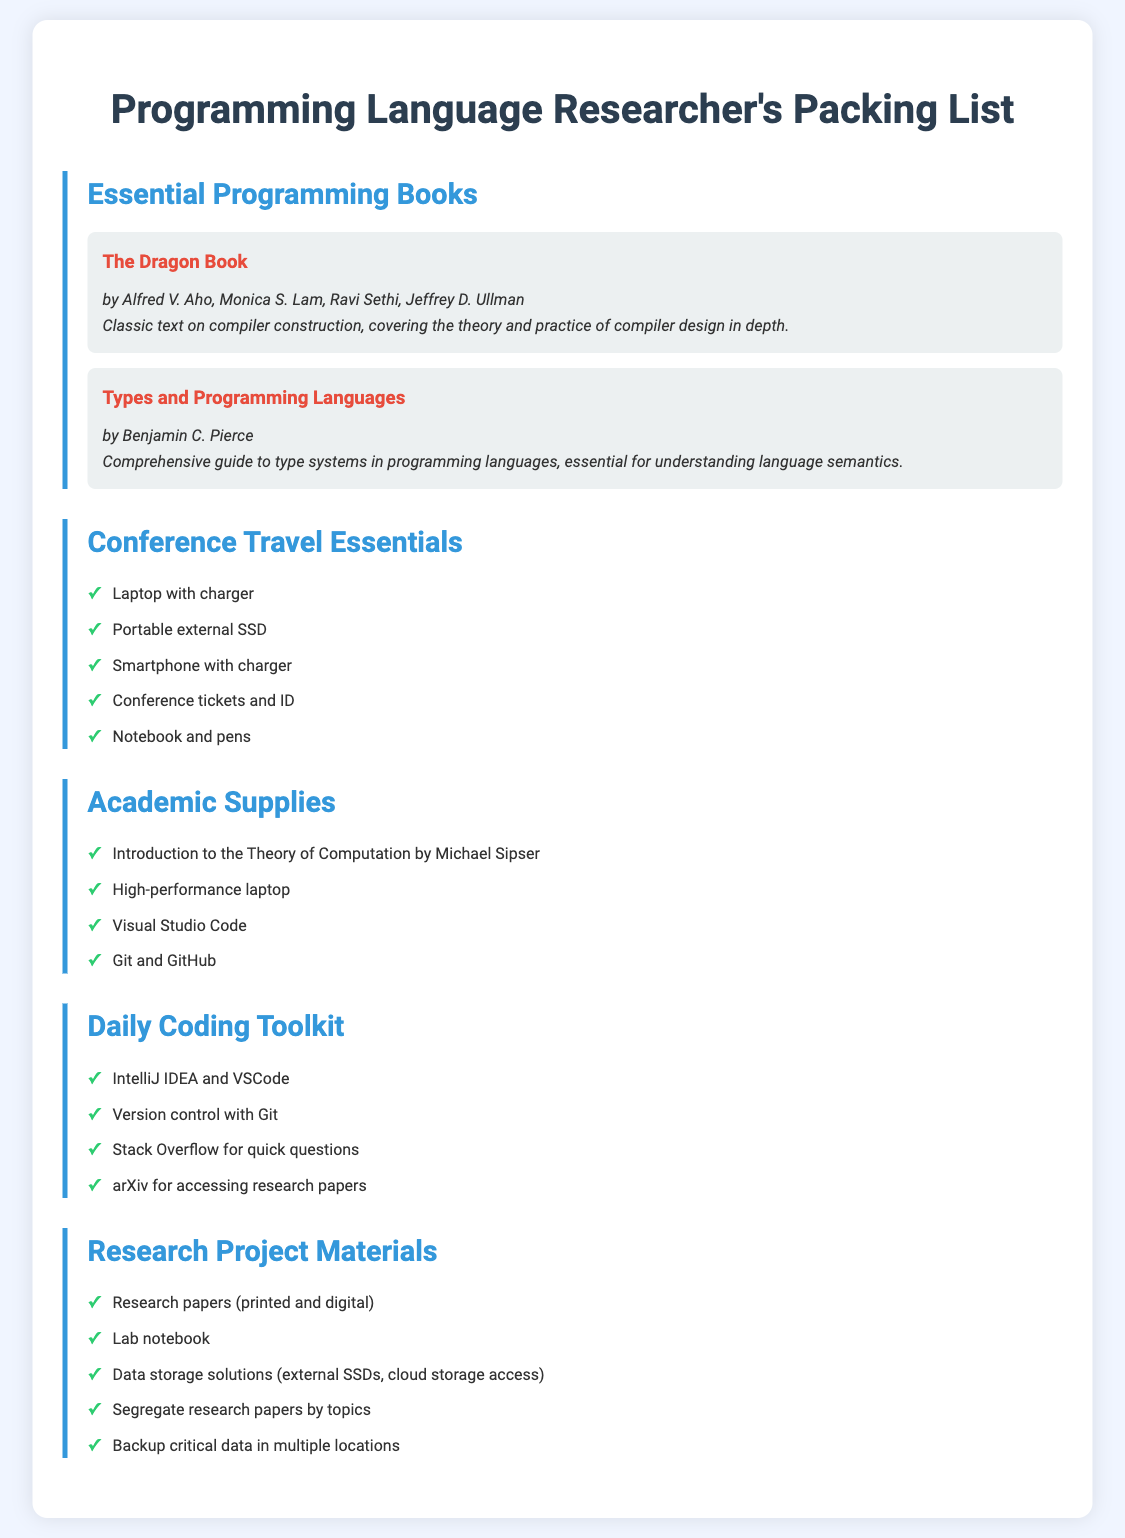What is the title of the classic text on compiler construction? The document lists "The Dragon Book" as the classic text on compiler construction.
Answer: The Dragon Book Who is the author of "Types and Programming Languages"? The document states that Benjamin C. Pierce is the author of "Types and Programming Languages".
Answer: Benjamin C. Pierce What gadget is listed as essential for conference travel? "Laptop with charger" is mentioned as one of the essential gadgets for conference travel.
Answer: Laptop with charger How many programming books are mentioned in the essential list? The document lists a total of 2 books under essential programming books.
Answer: 2 What type of development software is included in the academic supplies? The list includes "Visual Studio Code" as a type of development software.
Answer: Visual Studio Code What should you bring to store your research papers? The document suggests bringing "Research papers (printed and digital)" to store research papers.
Answer: Research papers Which item is recommended for quick questions during coding? "Stack Overflow" is recommended for quick questions related to coding.
Answer: Stack Overflow What should you do to ensure the safety of critical data? The document advises to "Backup critical data in multiple locations" for data safety.
Answer: Backup critical data in multiple locations What is suggested for organizing lab materials for research projects? The document mentions to "Segregate research papers by topics" for organizing lab materials.
Answer: Segregate research papers by topics 